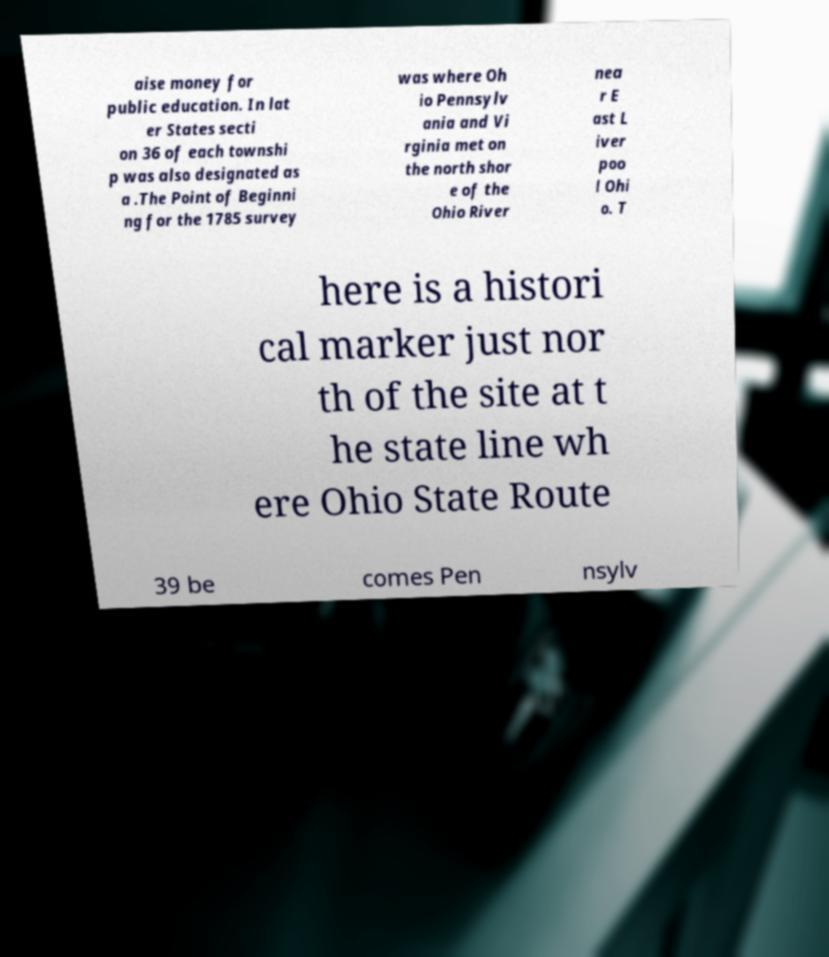There's text embedded in this image that I need extracted. Can you transcribe it verbatim? aise money for public education. In lat er States secti on 36 of each townshi p was also designated as a .The Point of Beginni ng for the 1785 survey was where Oh io Pennsylv ania and Vi rginia met on the north shor e of the Ohio River nea r E ast L iver poo l Ohi o. T here is a histori cal marker just nor th of the site at t he state line wh ere Ohio State Route 39 be comes Pen nsylv 